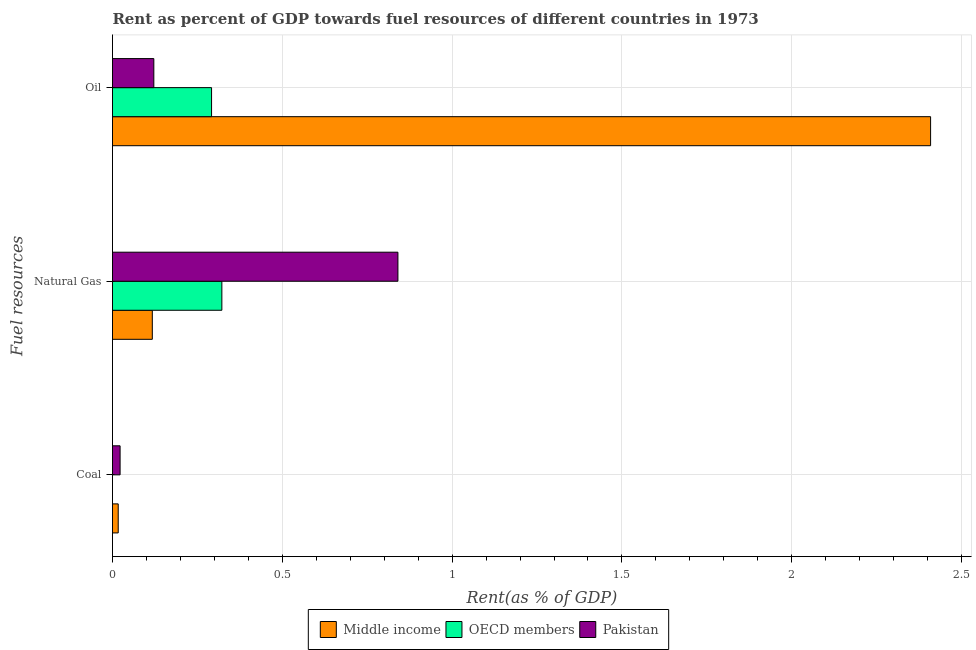How many different coloured bars are there?
Give a very brief answer. 3. How many groups of bars are there?
Ensure brevity in your answer.  3. Are the number of bars on each tick of the Y-axis equal?
Your response must be concise. Yes. How many bars are there on the 2nd tick from the top?
Make the answer very short. 3. How many bars are there on the 1st tick from the bottom?
Provide a short and direct response. 3. What is the label of the 2nd group of bars from the top?
Offer a very short reply. Natural Gas. What is the rent towards oil in Middle income?
Your answer should be very brief. 2.41. Across all countries, what is the maximum rent towards natural gas?
Your answer should be very brief. 0.84. Across all countries, what is the minimum rent towards oil?
Make the answer very short. 0.12. In which country was the rent towards natural gas minimum?
Your response must be concise. Middle income. What is the total rent towards natural gas in the graph?
Offer a terse response. 1.28. What is the difference between the rent towards natural gas in Pakistan and that in OECD members?
Provide a succinct answer. 0.52. What is the difference between the rent towards oil in Pakistan and the rent towards coal in OECD members?
Provide a succinct answer. 0.12. What is the average rent towards natural gas per country?
Provide a short and direct response. 0.43. What is the difference between the rent towards oil and rent towards natural gas in OECD members?
Provide a succinct answer. -0.03. In how many countries, is the rent towards natural gas greater than 1.4 %?
Provide a succinct answer. 0. What is the ratio of the rent towards oil in OECD members to that in Pakistan?
Your response must be concise. 2.4. What is the difference between the highest and the second highest rent towards oil?
Provide a short and direct response. 2.12. What is the difference between the highest and the lowest rent towards coal?
Provide a short and direct response. 0.02. Is the sum of the rent towards natural gas in Middle income and OECD members greater than the maximum rent towards oil across all countries?
Your answer should be compact. No. What does the 3rd bar from the top in Coal represents?
Your answer should be very brief. Middle income. What does the 1st bar from the bottom in Natural Gas represents?
Your answer should be compact. Middle income. Is it the case that in every country, the sum of the rent towards coal and rent towards natural gas is greater than the rent towards oil?
Your answer should be very brief. No. Are all the bars in the graph horizontal?
Provide a succinct answer. Yes. Are the values on the major ticks of X-axis written in scientific E-notation?
Give a very brief answer. No. Does the graph contain any zero values?
Your answer should be very brief. No. Does the graph contain grids?
Keep it short and to the point. Yes. What is the title of the graph?
Give a very brief answer. Rent as percent of GDP towards fuel resources of different countries in 1973. Does "Lithuania" appear as one of the legend labels in the graph?
Your answer should be very brief. No. What is the label or title of the X-axis?
Provide a short and direct response. Rent(as % of GDP). What is the label or title of the Y-axis?
Make the answer very short. Fuel resources. What is the Rent(as % of GDP) in Middle income in Coal?
Provide a succinct answer. 0.02. What is the Rent(as % of GDP) in OECD members in Coal?
Make the answer very short. 1.50641686702978e-6. What is the Rent(as % of GDP) of Pakistan in Coal?
Ensure brevity in your answer.  0.02. What is the Rent(as % of GDP) in Middle income in Natural Gas?
Provide a succinct answer. 0.12. What is the Rent(as % of GDP) of OECD members in Natural Gas?
Provide a short and direct response. 0.32. What is the Rent(as % of GDP) in Pakistan in Natural Gas?
Offer a terse response. 0.84. What is the Rent(as % of GDP) in Middle income in Oil?
Your answer should be compact. 2.41. What is the Rent(as % of GDP) of OECD members in Oil?
Your response must be concise. 0.29. What is the Rent(as % of GDP) of Pakistan in Oil?
Give a very brief answer. 0.12. Across all Fuel resources, what is the maximum Rent(as % of GDP) of Middle income?
Keep it short and to the point. 2.41. Across all Fuel resources, what is the maximum Rent(as % of GDP) of OECD members?
Keep it short and to the point. 0.32. Across all Fuel resources, what is the maximum Rent(as % of GDP) of Pakistan?
Provide a short and direct response. 0.84. Across all Fuel resources, what is the minimum Rent(as % of GDP) of Middle income?
Offer a terse response. 0.02. Across all Fuel resources, what is the minimum Rent(as % of GDP) in OECD members?
Keep it short and to the point. 1.50641686702978e-6. Across all Fuel resources, what is the minimum Rent(as % of GDP) in Pakistan?
Your answer should be very brief. 0.02. What is the total Rent(as % of GDP) in Middle income in the graph?
Your response must be concise. 2.54. What is the total Rent(as % of GDP) in OECD members in the graph?
Offer a terse response. 0.61. What is the total Rent(as % of GDP) of Pakistan in the graph?
Make the answer very short. 0.98. What is the difference between the Rent(as % of GDP) of Middle income in Coal and that in Natural Gas?
Keep it short and to the point. -0.1. What is the difference between the Rent(as % of GDP) of OECD members in Coal and that in Natural Gas?
Provide a short and direct response. -0.32. What is the difference between the Rent(as % of GDP) in Pakistan in Coal and that in Natural Gas?
Provide a succinct answer. -0.82. What is the difference between the Rent(as % of GDP) in Middle income in Coal and that in Oil?
Provide a short and direct response. -2.39. What is the difference between the Rent(as % of GDP) in OECD members in Coal and that in Oil?
Your answer should be very brief. -0.29. What is the difference between the Rent(as % of GDP) of Pakistan in Coal and that in Oil?
Your response must be concise. -0.1. What is the difference between the Rent(as % of GDP) in Middle income in Natural Gas and that in Oil?
Your response must be concise. -2.29. What is the difference between the Rent(as % of GDP) in OECD members in Natural Gas and that in Oil?
Make the answer very short. 0.03. What is the difference between the Rent(as % of GDP) in Pakistan in Natural Gas and that in Oil?
Make the answer very short. 0.72. What is the difference between the Rent(as % of GDP) of Middle income in Coal and the Rent(as % of GDP) of OECD members in Natural Gas?
Provide a succinct answer. -0.31. What is the difference between the Rent(as % of GDP) in Middle income in Coal and the Rent(as % of GDP) in Pakistan in Natural Gas?
Your answer should be compact. -0.82. What is the difference between the Rent(as % of GDP) of OECD members in Coal and the Rent(as % of GDP) of Pakistan in Natural Gas?
Ensure brevity in your answer.  -0.84. What is the difference between the Rent(as % of GDP) of Middle income in Coal and the Rent(as % of GDP) of OECD members in Oil?
Ensure brevity in your answer.  -0.27. What is the difference between the Rent(as % of GDP) of Middle income in Coal and the Rent(as % of GDP) of Pakistan in Oil?
Give a very brief answer. -0.1. What is the difference between the Rent(as % of GDP) in OECD members in Coal and the Rent(as % of GDP) in Pakistan in Oil?
Provide a succinct answer. -0.12. What is the difference between the Rent(as % of GDP) of Middle income in Natural Gas and the Rent(as % of GDP) of OECD members in Oil?
Provide a short and direct response. -0.17. What is the difference between the Rent(as % of GDP) in Middle income in Natural Gas and the Rent(as % of GDP) in Pakistan in Oil?
Provide a succinct answer. -0. What is the difference between the Rent(as % of GDP) in OECD members in Natural Gas and the Rent(as % of GDP) in Pakistan in Oil?
Your answer should be compact. 0.2. What is the average Rent(as % of GDP) in Middle income per Fuel resources?
Give a very brief answer. 0.85. What is the average Rent(as % of GDP) of OECD members per Fuel resources?
Your answer should be compact. 0.2. What is the average Rent(as % of GDP) in Pakistan per Fuel resources?
Your answer should be compact. 0.33. What is the difference between the Rent(as % of GDP) in Middle income and Rent(as % of GDP) in OECD members in Coal?
Provide a succinct answer. 0.02. What is the difference between the Rent(as % of GDP) in Middle income and Rent(as % of GDP) in Pakistan in Coal?
Make the answer very short. -0.01. What is the difference between the Rent(as % of GDP) in OECD members and Rent(as % of GDP) in Pakistan in Coal?
Your answer should be compact. -0.02. What is the difference between the Rent(as % of GDP) in Middle income and Rent(as % of GDP) in OECD members in Natural Gas?
Ensure brevity in your answer.  -0.2. What is the difference between the Rent(as % of GDP) in Middle income and Rent(as % of GDP) in Pakistan in Natural Gas?
Make the answer very short. -0.72. What is the difference between the Rent(as % of GDP) of OECD members and Rent(as % of GDP) of Pakistan in Natural Gas?
Your answer should be very brief. -0.52. What is the difference between the Rent(as % of GDP) of Middle income and Rent(as % of GDP) of OECD members in Oil?
Your answer should be very brief. 2.12. What is the difference between the Rent(as % of GDP) in Middle income and Rent(as % of GDP) in Pakistan in Oil?
Your answer should be very brief. 2.29. What is the difference between the Rent(as % of GDP) of OECD members and Rent(as % of GDP) of Pakistan in Oil?
Make the answer very short. 0.17. What is the ratio of the Rent(as % of GDP) in Middle income in Coal to that in Natural Gas?
Give a very brief answer. 0.14. What is the ratio of the Rent(as % of GDP) in OECD members in Coal to that in Natural Gas?
Offer a terse response. 0. What is the ratio of the Rent(as % of GDP) of Pakistan in Coal to that in Natural Gas?
Provide a succinct answer. 0.03. What is the ratio of the Rent(as % of GDP) of Middle income in Coal to that in Oil?
Give a very brief answer. 0.01. What is the ratio of the Rent(as % of GDP) in Pakistan in Coal to that in Oil?
Ensure brevity in your answer.  0.18. What is the ratio of the Rent(as % of GDP) of Middle income in Natural Gas to that in Oil?
Offer a terse response. 0.05. What is the ratio of the Rent(as % of GDP) of OECD members in Natural Gas to that in Oil?
Give a very brief answer. 1.1. What is the ratio of the Rent(as % of GDP) in Pakistan in Natural Gas to that in Oil?
Keep it short and to the point. 6.91. What is the difference between the highest and the second highest Rent(as % of GDP) in Middle income?
Offer a terse response. 2.29. What is the difference between the highest and the second highest Rent(as % of GDP) in OECD members?
Your response must be concise. 0.03. What is the difference between the highest and the second highest Rent(as % of GDP) in Pakistan?
Make the answer very short. 0.72. What is the difference between the highest and the lowest Rent(as % of GDP) in Middle income?
Make the answer very short. 2.39. What is the difference between the highest and the lowest Rent(as % of GDP) of OECD members?
Give a very brief answer. 0.32. What is the difference between the highest and the lowest Rent(as % of GDP) of Pakistan?
Keep it short and to the point. 0.82. 